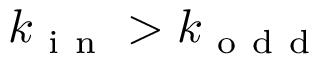Convert formula to latex. <formula><loc_0><loc_0><loc_500><loc_500>k _ { i n } > k _ { o d d }</formula> 